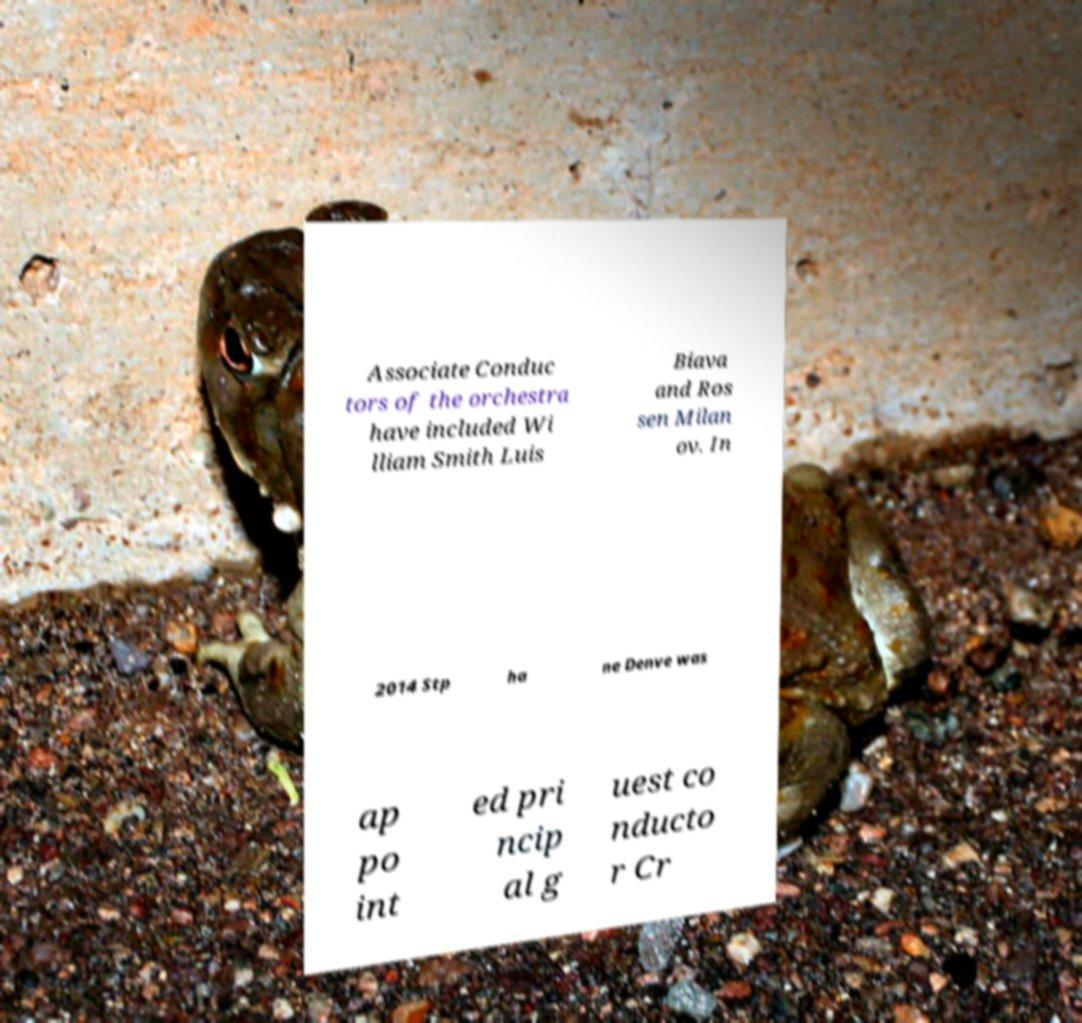I need the written content from this picture converted into text. Can you do that? Associate Conduc tors of the orchestra have included Wi lliam Smith Luis Biava and Ros sen Milan ov. In 2014 Stp ha ne Denve was ap po int ed pri ncip al g uest co nducto r Cr 